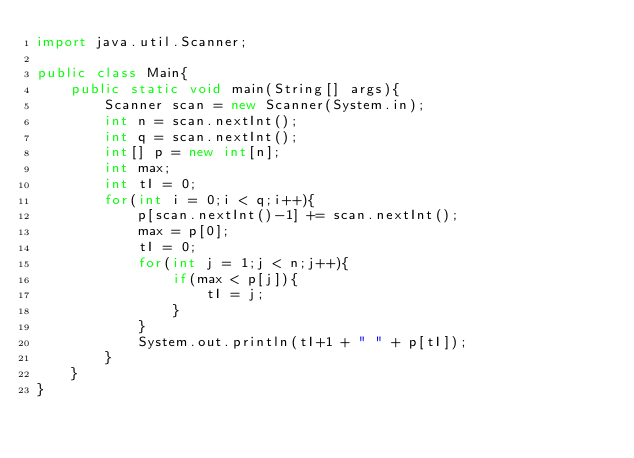Convert code to text. <code><loc_0><loc_0><loc_500><loc_500><_Java_>import java.util.Scanner;

public class Main{
	public static void main(String[] args){
		Scanner scan = new Scanner(System.in);
		int n = scan.nextInt();
		int q = scan.nextInt();
		int[] p = new int[n];
		int max;
		int tI = 0;
		for(int i = 0;i < q;i++){
			p[scan.nextInt()-1] += scan.nextInt();
			max = p[0];
			tI = 0;
			for(int j = 1;j < n;j++){
				if(max < p[j]){
					tI = j;
				}
			}
			System.out.println(tI+1 + " " + p[tI]);
		}
	}
}</code> 